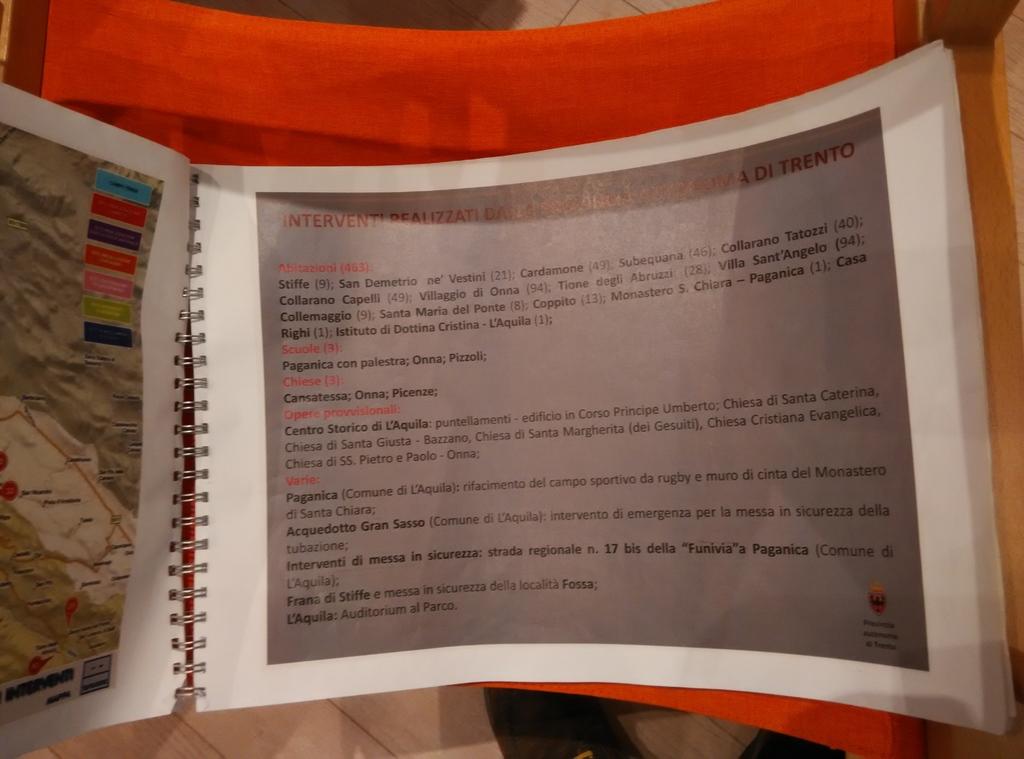What is one of the foreign words on this page?
Make the answer very short. Stiffe. 